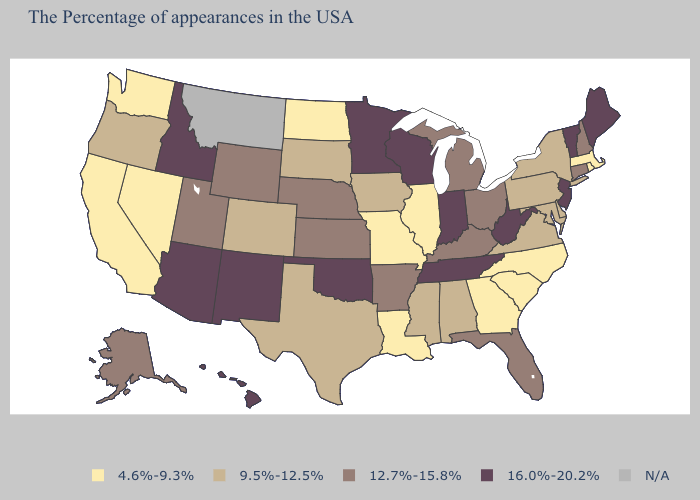What is the highest value in states that border Kentucky?
Short answer required. 16.0%-20.2%. What is the lowest value in the USA?
Give a very brief answer. 4.6%-9.3%. What is the value of Maine?
Short answer required. 16.0%-20.2%. Does the first symbol in the legend represent the smallest category?
Concise answer only. Yes. Which states have the lowest value in the Northeast?
Short answer required. Massachusetts, Rhode Island. Does Wyoming have the highest value in the USA?
Quick response, please. No. Name the states that have a value in the range 9.5%-12.5%?
Answer briefly. New York, Delaware, Maryland, Pennsylvania, Virginia, Alabama, Mississippi, Iowa, Texas, South Dakota, Colorado, Oregon. What is the value of Michigan?
Give a very brief answer. 12.7%-15.8%. What is the value of West Virginia?
Keep it brief. 16.0%-20.2%. Which states have the lowest value in the USA?
Be succinct. Massachusetts, Rhode Island, North Carolina, South Carolina, Georgia, Illinois, Louisiana, Missouri, North Dakota, Nevada, California, Washington. Among the states that border Texas , which have the lowest value?
Keep it brief. Louisiana. Among the states that border Illinois , which have the lowest value?
Concise answer only. Missouri. Among the states that border Mississippi , which have the lowest value?
Be succinct. Louisiana. What is the lowest value in the West?
Write a very short answer. 4.6%-9.3%. What is the highest value in the Northeast ?
Answer briefly. 16.0%-20.2%. 